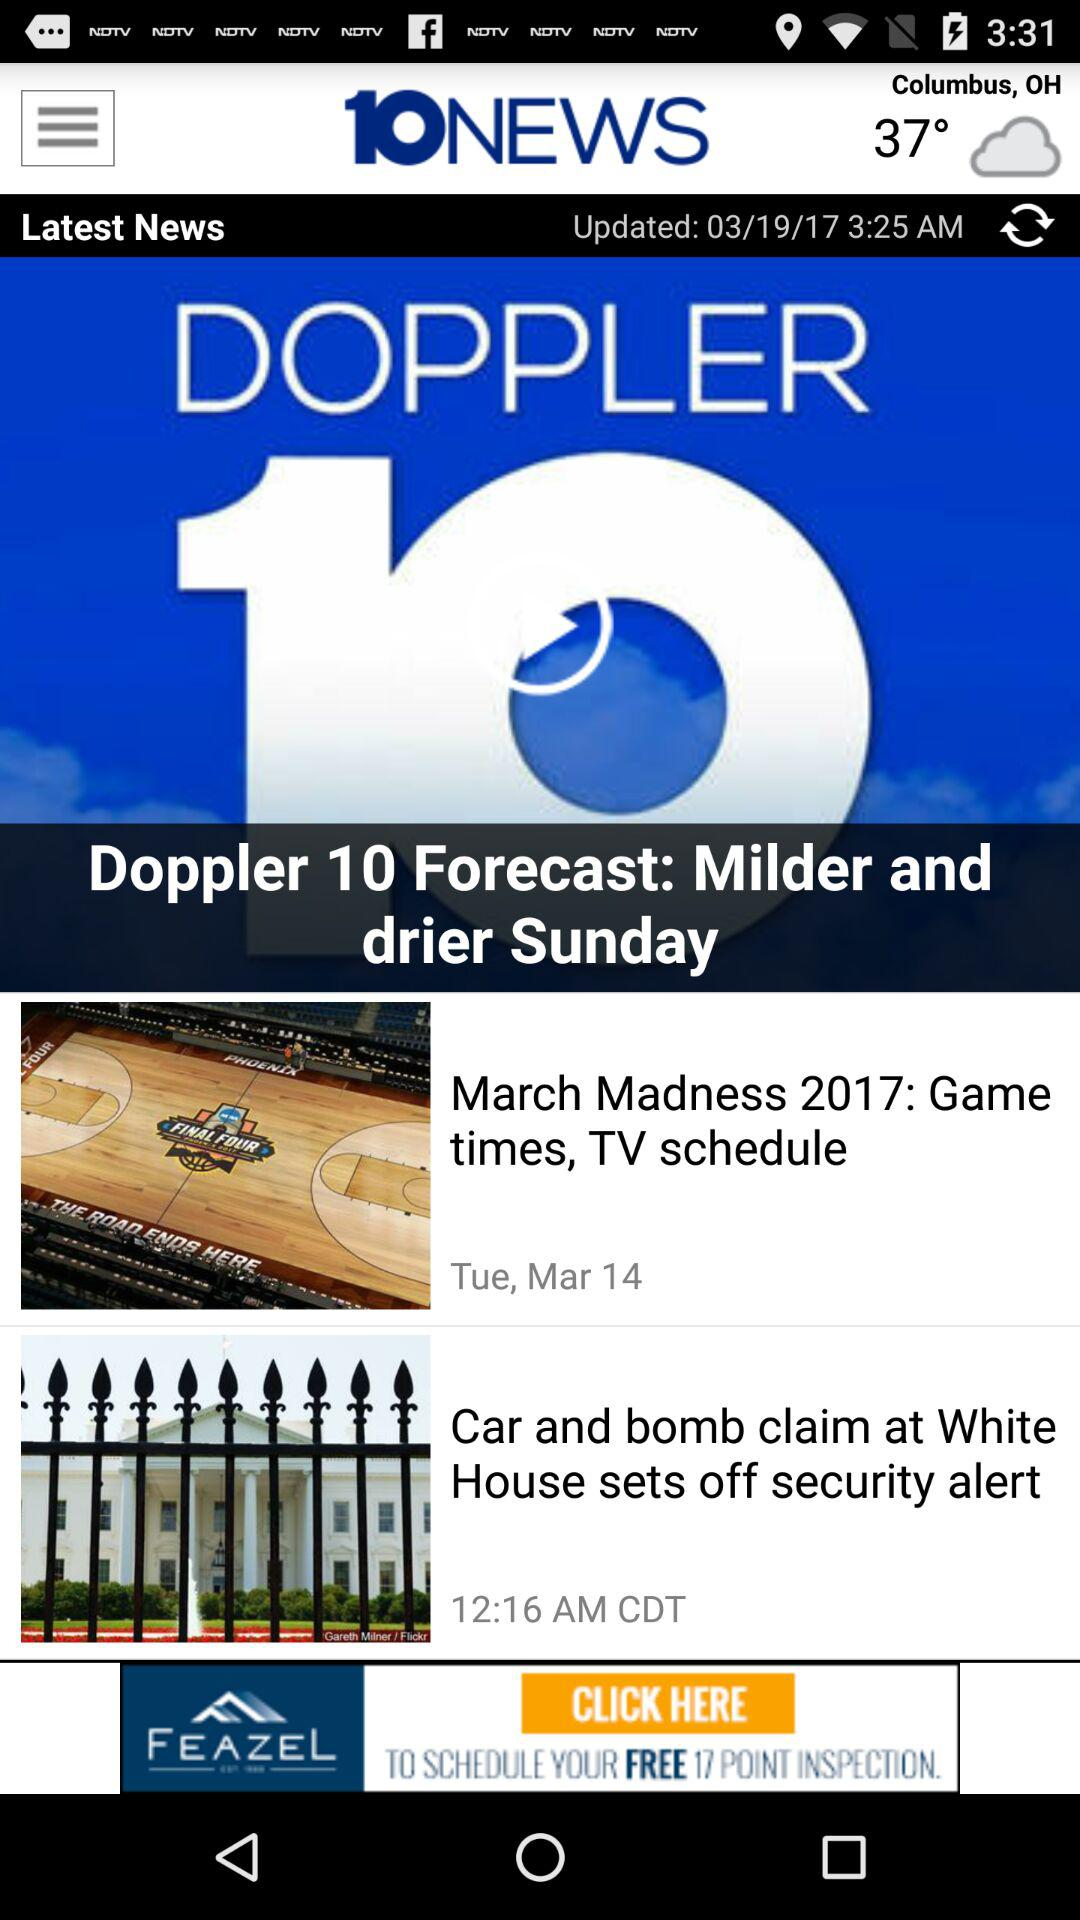What is the news channel name? The news channel name is "ABC 10NEWS". 